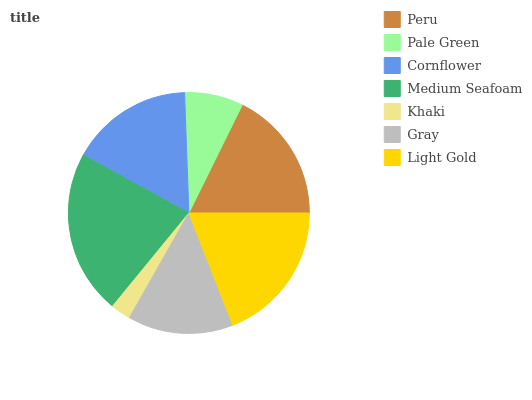Is Khaki the minimum?
Answer yes or no. Yes. Is Medium Seafoam the maximum?
Answer yes or no. Yes. Is Pale Green the minimum?
Answer yes or no. No. Is Pale Green the maximum?
Answer yes or no. No. Is Peru greater than Pale Green?
Answer yes or no. Yes. Is Pale Green less than Peru?
Answer yes or no. Yes. Is Pale Green greater than Peru?
Answer yes or no. No. Is Peru less than Pale Green?
Answer yes or no. No. Is Cornflower the high median?
Answer yes or no. Yes. Is Cornflower the low median?
Answer yes or no. Yes. Is Pale Green the high median?
Answer yes or no. No. Is Medium Seafoam the low median?
Answer yes or no. No. 